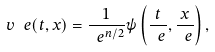Convert formula to latex. <formula><loc_0><loc_0><loc_500><loc_500>v ^ { \ } e ( t , x ) = \frac { 1 } { \ e ^ { n / 2 } } \psi \left ( \frac { t } { \ e } , \frac { x } { \ e } \right ) ,</formula> 